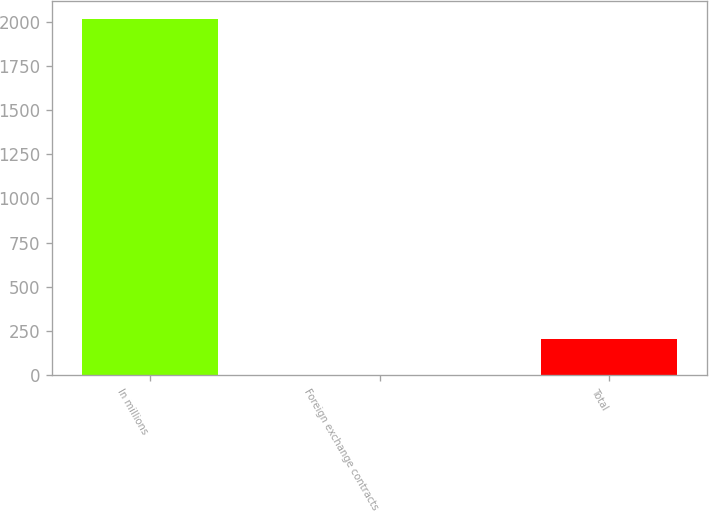<chart> <loc_0><loc_0><loc_500><loc_500><bar_chart><fcel>In millions<fcel>Foreign exchange contracts<fcel>Total<nl><fcel>2016<fcel>4<fcel>205.2<nl></chart> 